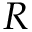Convert formula to latex. <formula><loc_0><loc_0><loc_500><loc_500>R</formula> 